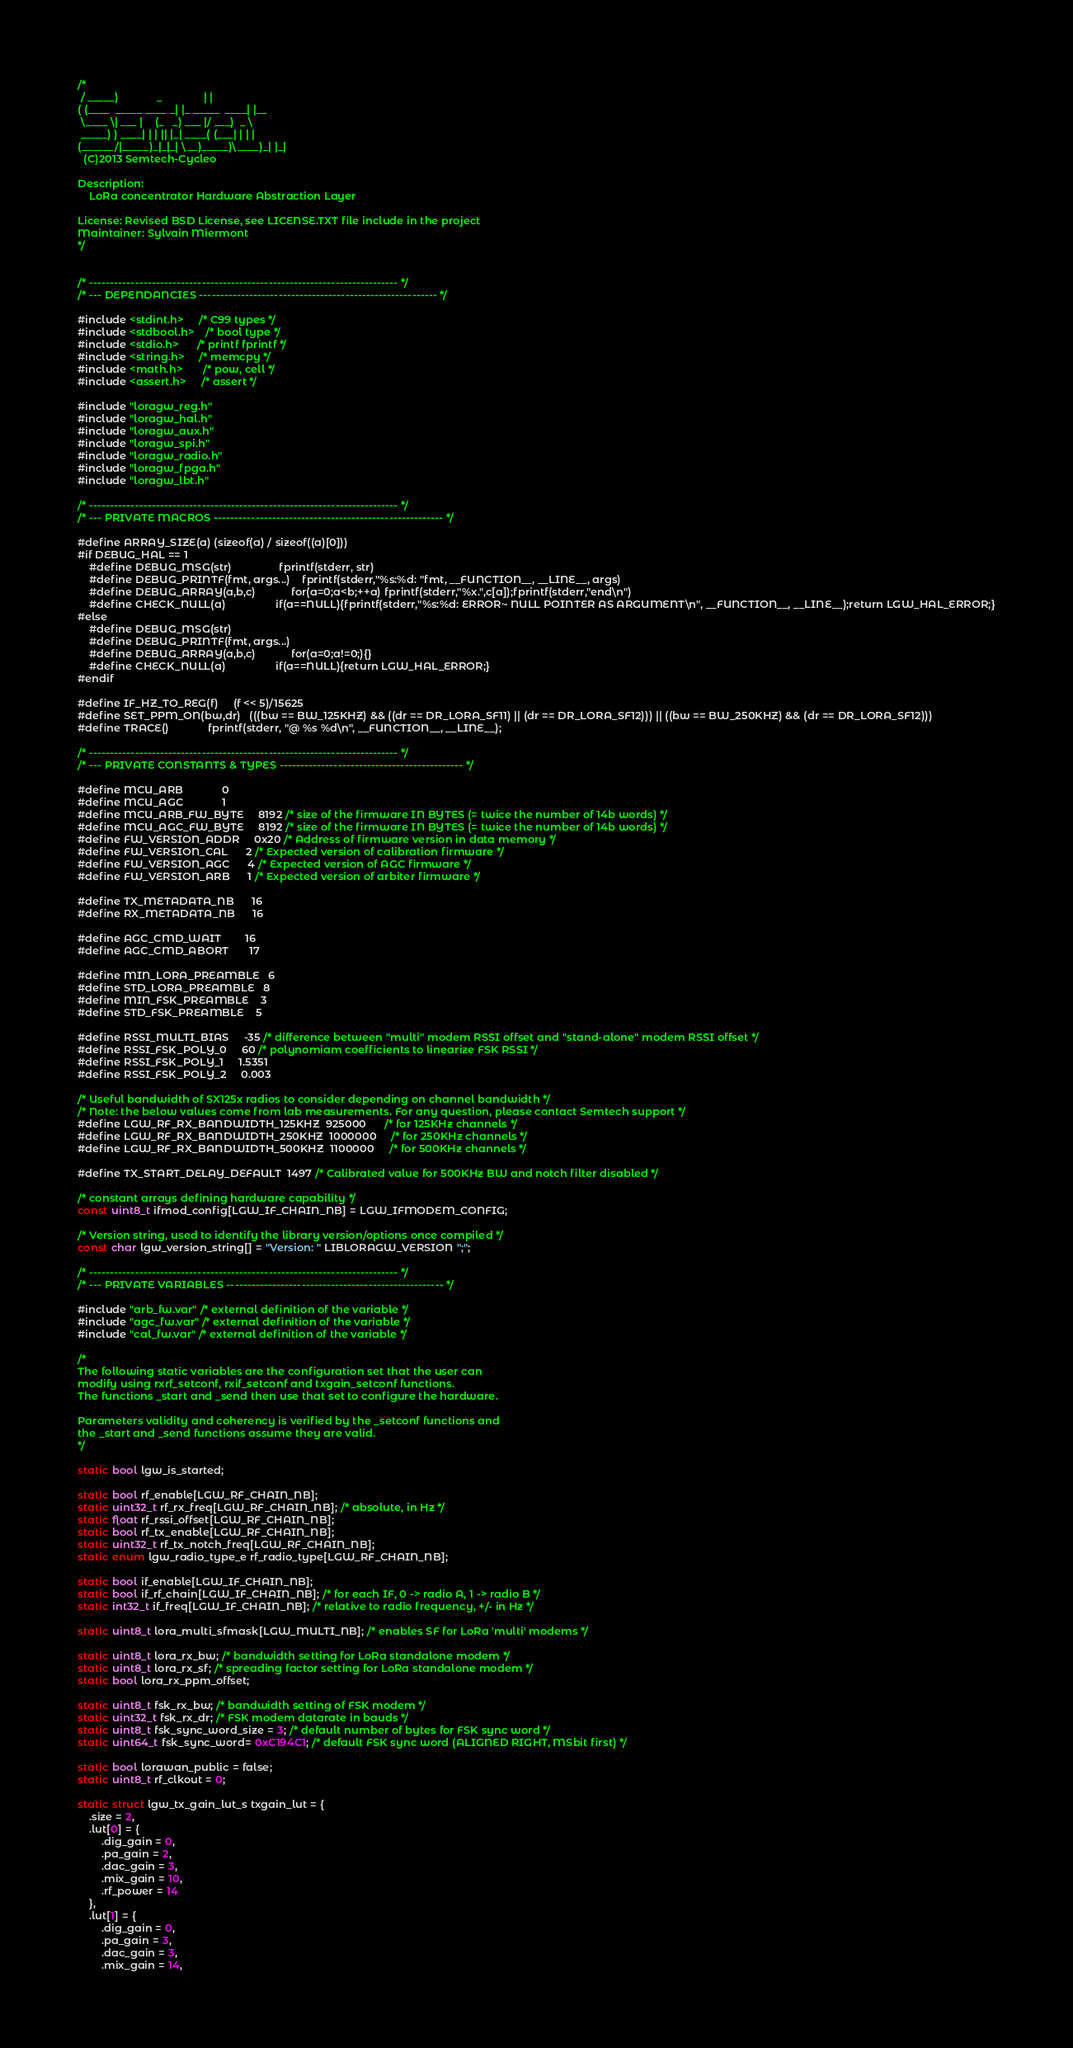<code> <loc_0><loc_0><loc_500><loc_500><_C_>/*
 / _____)             _              | |
( (____  _____ ____ _| |_ _____  ____| |__
 \____ \| ___ |    (_   _) ___ |/ ___)  _ \
 _____) ) ____| | | || |_| ____( (___| | | |
(______/|_____)_|_|_| \__)_____)\____)_| |_|
  (C)2013 Semtech-Cycleo

Description:
    LoRa concentrator Hardware Abstraction Layer

License: Revised BSD License, see LICENSE.TXT file include in the project
Maintainer: Sylvain Miermont
*/


/* -------------------------------------------------------------------------- */
/* --- DEPENDANCIES --------------------------------------------------------- */

#include <stdint.h>     /* C99 types */
#include <stdbool.h>    /* bool type */
#include <stdio.h>      /* printf fprintf */
#include <string.h>     /* memcpy */
#include <math.h>       /* pow, cell */
#include <assert.h>     /* assert */

#include "loragw_reg.h"
#include "loragw_hal.h"
#include "loragw_aux.h"
#include "loragw_spi.h"
#include "loragw_radio.h"
#include "loragw_fpga.h"
#include "loragw_lbt.h"

/* -------------------------------------------------------------------------- */
/* --- PRIVATE MACROS ------------------------------------------------------- */

#define ARRAY_SIZE(a) (sizeof(a) / sizeof((a)[0]))
#if DEBUG_HAL == 1
    #define DEBUG_MSG(str)                fprintf(stderr, str)
    #define DEBUG_PRINTF(fmt, args...)    fprintf(stderr,"%s:%d: "fmt, __FUNCTION__, __LINE__, args)
    #define DEBUG_ARRAY(a,b,c)            for(a=0;a<b;++a) fprintf(stderr,"%x.",c[a]);fprintf(stderr,"end\n")
    #define CHECK_NULL(a)                 if(a==NULL){fprintf(stderr,"%s:%d: ERROR~ NULL POINTER AS ARGUMENT\n", __FUNCTION__, __LINE__);return LGW_HAL_ERROR;}
#else
    #define DEBUG_MSG(str)
    #define DEBUG_PRINTF(fmt, args...)
    #define DEBUG_ARRAY(a,b,c)            for(a=0;a!=0;){}
    #define CHECK_NULL(a)                 if(a==NULL){return LGW_HAL_ERROR;}
#endif

#define IF_HZ_TO_REG(f)     (f << 5)/15625
#define SET_PPM_ON(bw,dr)   (((bw == BW_125KHZ) && ((dr == DR_LORA_SF11) || (dr == DR_LORA_SF12))) || ((bw == BW_250KHZ) && (dr == DR_LORA_SF12)))
#define TRACE()             fprintf(stderr, "@ %s %d\n", __FUNCTION__, __LINE__);

/* -------------------------------------------------------------------------- */
/* --- PRIVATE CONSTANTS & TYPES -------------------------------------------- */

#define MCU_ARB             0
#define MCU_AGC             1
#define MCU_ARB_FW_BYTE     8192 /* size of the firmware IN BYTES (= twice the number of 14b words) */
#define MCU_AGC_FW_BYTE     8192 /* size of the firmware IN BYTES (= twice the number of 14b words) */
#define FW_VERSION_ADDR     0x20 /* Address of firmware version in data memory */
#define FW_VERSION_CAL      2 /* Expected version of calibration firmware */
#define FW_VERSION_AGC      4 /* Expected version of AGC firmware */
#define FW_VERSION_ARB      1 /* Expected version of arbiter firmware */

#define TX_METADATA_NB      16
#define RX_METADATA_NB      16

#define AGC_CMD_WAIT        16
#define AGC_CMD_ABORT       17

#define MIN_LORA_PREAMBLE   6
#define STD_LORA_PREAMBLE   8
#define MIN_FSK_PREAMBLE    3
#define STD_FSK_PREAMBLE    5

#define RSSI_MULTI_BIAS     -35 /* difference between "multi" modem RSSI offset and "stand-alone" modem RSSI offset */
#define RSSI_FSK_POLY_0     60 /* polynomiam coefficients to linearize FSK RSSI */
#define RSSI_FSK_POLY_1     1.5351
#define RSSI_FSK_POLY_2     0.003

/* Useful bandwidth of SX125x radios to consider depending on channel bandwidth */
/* Note: the below values come from lab measurements. For any question, please contact Semtech support */
#define LGW_RF_RX_BANDWIDTH_125KHZ  925000      /* for 125KHz channels */
#define LGW_RF_RX_BANDWIDTH_250KHZ  1000000     /* for 250KHz channels */
#define LGW_RF_RX_BANDWIDTH_500KHZ  1100000     /* for 500KHz channels */

#define TX_START_DELAY_DEFAULT  1497 /* Calibrated value for 500KHz BW and notch filter disabled */

/* constant arrays defining hardware capability */
const uint8_t ifmod_config[LGW_IF_CHAIN_NB] = LGW_IFMODEM_CONFIG;

/* Version string, used to identify the library version/options once compiled */
const char lgw_version_string[] = "Version: " LIBLORAGW_VERSION ";";

/* -------------------------------------------------------------------------- */
/* --- PRIVATE VARIABLES ---------------------------------------------------- */

#include "arb_fw.var" /* external definition of the variable */
#include "agc_fw.var" /* external definition of the variable */
#include "cal_fw.var" /* external definition of the variable */

/*
The following static variables are the configuration set that the user can
modify using rxrf_setconf, rxif_setconf and txgain_setconf functions.
The functions _start and _send then use that set to configure the hardware.

Parameters validity and coherency is verified by the _setconf functions and
the _start and _send functions assume they are valid.
*/

static bool lgw_is_started;

static bool rf_enable[LGW_RF_CHAIN_NB];
static uint32_t rf_rx_freq[LGW_RF_CHAIN_NB]; /* absolute, in Hz */
static float rf_rssi_offset[LGW_RF_CHAIN_NB];
static bool rf_tx_enable[LGW_RF_CHAIN_NB];
static uint32_t rf_tx_notch_freq[LGW_RF_CHAIN_NB];
static enum lgw_radio_type_e rf_radio_type[LGW_RF_CHAIN_NB];

static bool if_enable[LGW_IF_CHAIN_NB];
static bool if_rf_chain[LGW_IF_CHAIN_NB]; /* for each IF, 0 -> radio A, 1 -> radio B */
static int32_t if_freq[LGW_IF_CHAIN_NB]; /* relative to radio frequency, +/- in Hz */

static uint8_t lora_multi_sfmask[LGW_MULTI_NB]; /* enables SF for LoRa 'multi' modems */

static uint8_t lora_rx_bw; /* bandwidth setting for LoRa standalone modem */
static uint8_t lora_rx_sf; /* spreading factor setting for LoRa standalone modem */
static bool lora_rx_ppm_offset;

static uint8_t fsk_rx_bw; /* bandwidth setting of FSK modem */
static uint32_t fsk_rx_dr; /* FSK modem datarate in bauds */
static uint8_t fsk_sync_word_size = 3; /* default number of bytes for FSK sync word */
static uint64_t fsk_sync_word= 0xC194C1; /* default FSK sync word (ALIGNED RIGHT, MSbit first) */

static bool lorawan_public = false;
static uint8_t rf_clkout = 0;

static struct lgw_tx_gain_lut_s txgain_lut = {
    .size = 2,
    .lut[0] = {
        .dig_gain = 0,
        .pa_gain = 2,
        .dac_gain = 3,
        .mix_gain = 10,
        .rf_power = 14
    },
    .lut[1] = {
        .dig_gain = 0,
        .pa_gain = 3,
        .dac_gain = 3,
        .mix_gain = 14,</code> 